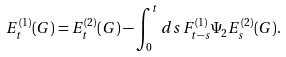<formula> <loc_0><loc_0><loc_500><loc_500>E ^ { ( 1 ) } _ { t } ( G ) = E ^ { ( 2 ) } _ { t } ( G ) - \int _ { 0 } ^ { t } d s \, F ^ { ( 1 ) } _ { t - s } \Psi _ { 2 } E ^ { ( 2 ) } _ { s } ( G ) .</formula> 